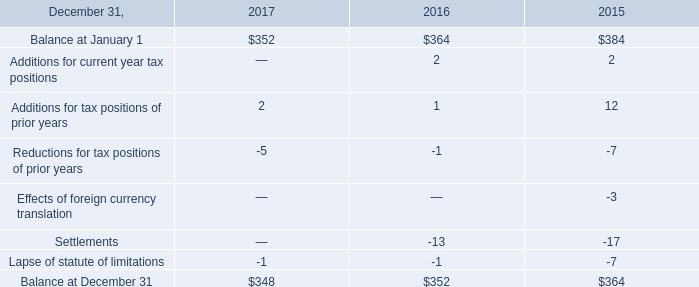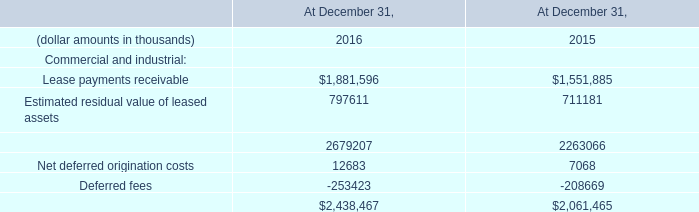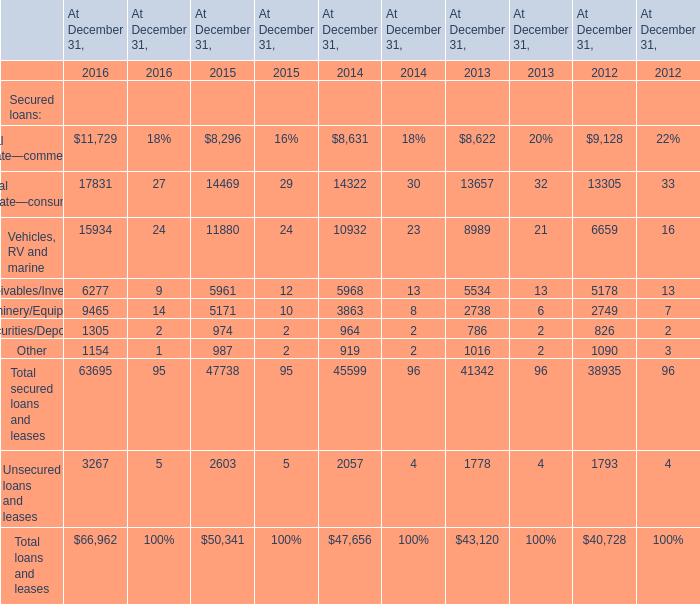What is the sum of Deferred fees of At December 31, 2016, Machinery/Equipment of At December 31, 2016, and Total secured loans and leases of At December 31, 2016 ? 
Computations: ((253423.0 + 9465.0) + 63695.0)
Answer: 326583.0. 